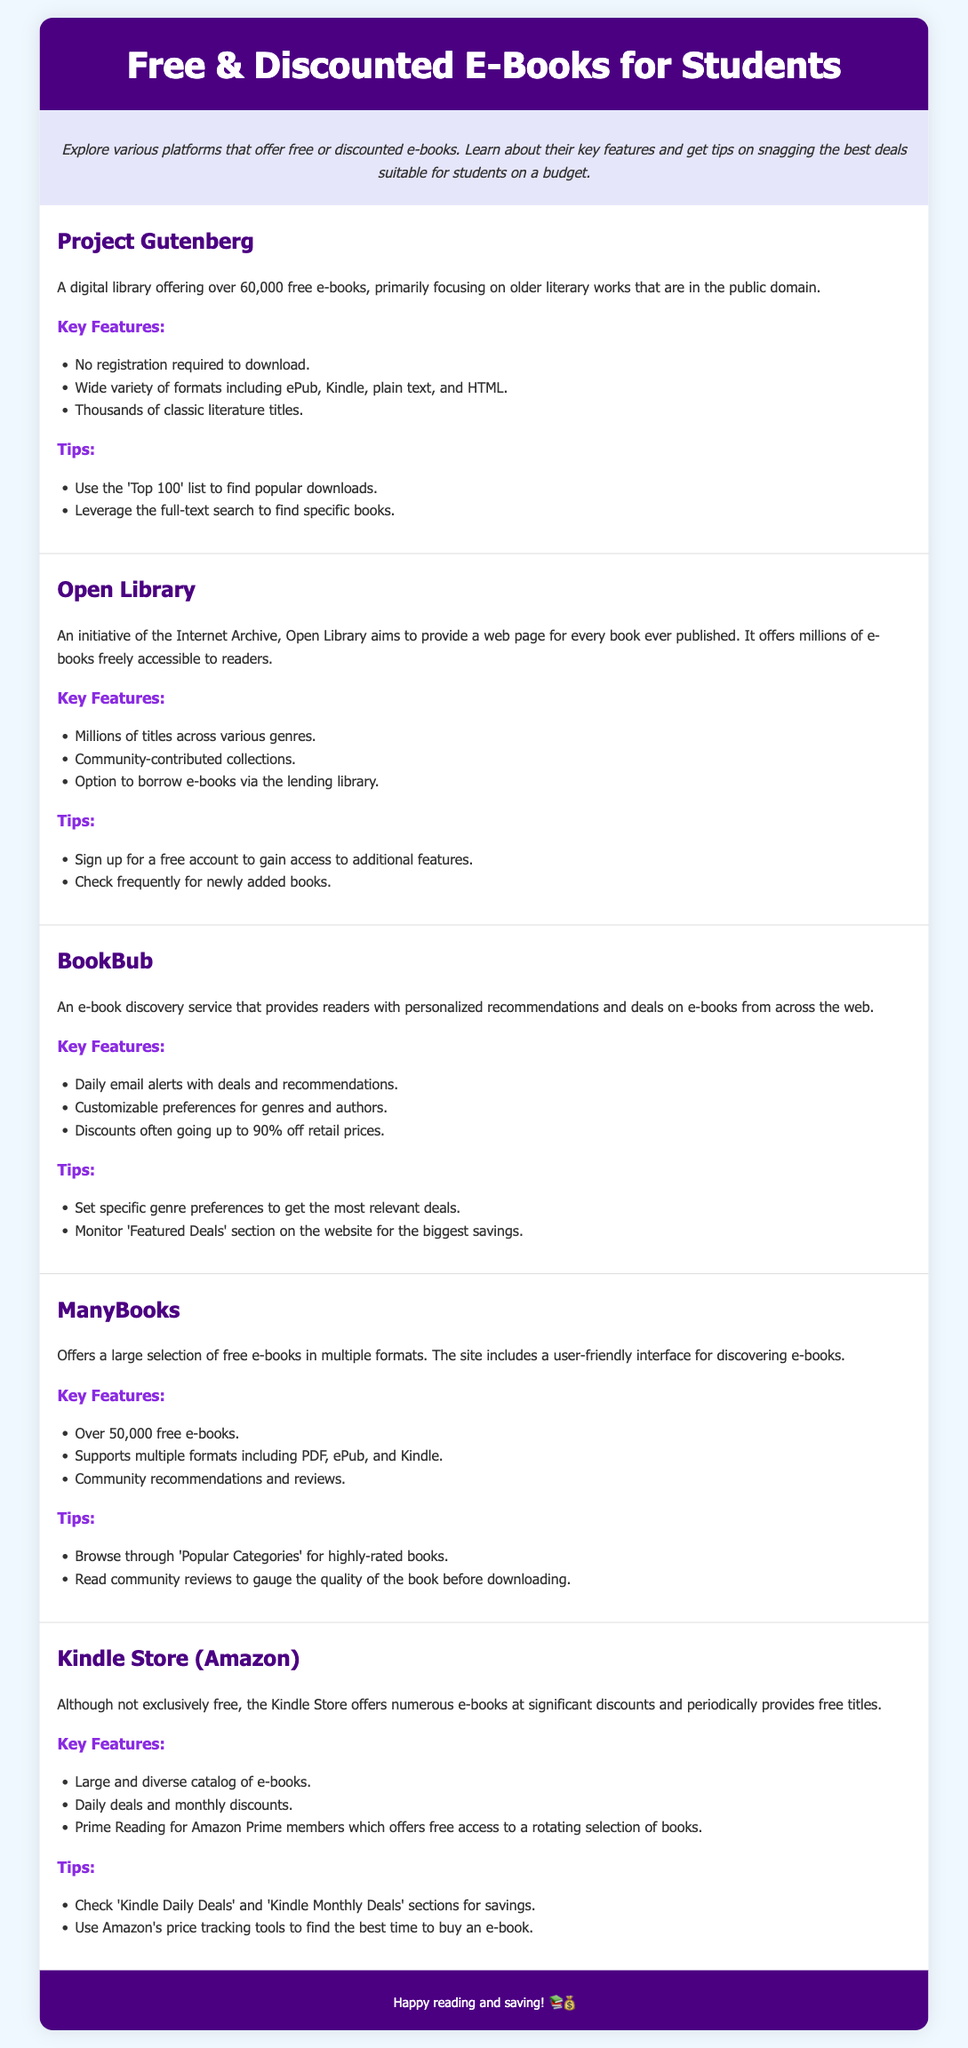what is the main purpose of the document? The document aims to explore various platforms that offer free or discounted e-books and provide tips for students on a budget.
Answer: to explore platforms offering free or discounted e-books how many free e-books does Project Gutenberg offer? The document states that Project Gutenberg offers over 60,000 free e-books.
Answer: over 60,000 which platform allows borrowing e-books via a lending library? Open Library is mentioned as allowing users to borrow e-books through its lending library feature.
Answer: Open Library what percentage of discounts can BookBub offer? The document mentions that BookBub offers discounts often going up to 90% off retail prices.
Answer: up to 90% which platform offers Prime Reading for free access to books? The Kindle Store (Amazon) is highlighted as offering Prime Reading for Amazon Prime members.
Answer: Kindle Store (Amazon) what is a tip for Project Gutenberg users to find books? The document suggests using the 'Top 100' list to find popular downloads as a tip for Project Gutenberg users.
Answer: use the 'Top 100' list how many platforms are described in the document? There are five platforms described, as each is detailed with its features and tips.
Answer: five what genre preferences can BookBub users customize? Users can customize preferences for genres and authors according to the document.
Answer: genres and authors what types of formats does ManyBooks support? ManyBooks supports multiple formats including PDF, ePub, and Kindle.
Answer: PDF, ePub, and Kindle 